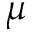<formula> <loc_0><loc_0><loc_500><loc_500>\mu</formula> 